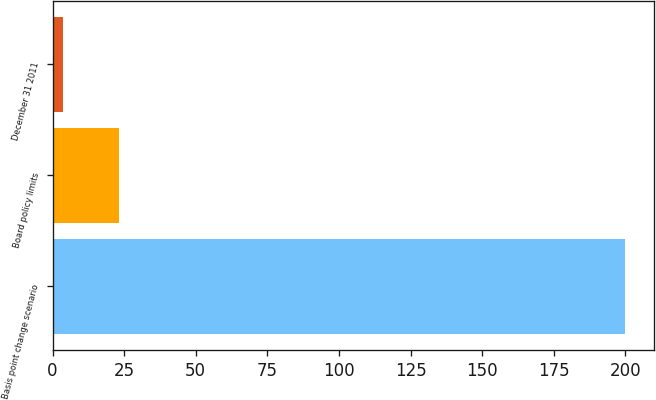Convert chart. <chart><loc_0><loc_0><loc_500><loc_500><bar_chart><fcel>Basis point change scenario<fcel>Board policy limits<fcel>December 31 2011<nl><fcel>200<fcel>23.24<fcel>3.6<nl></chart> 